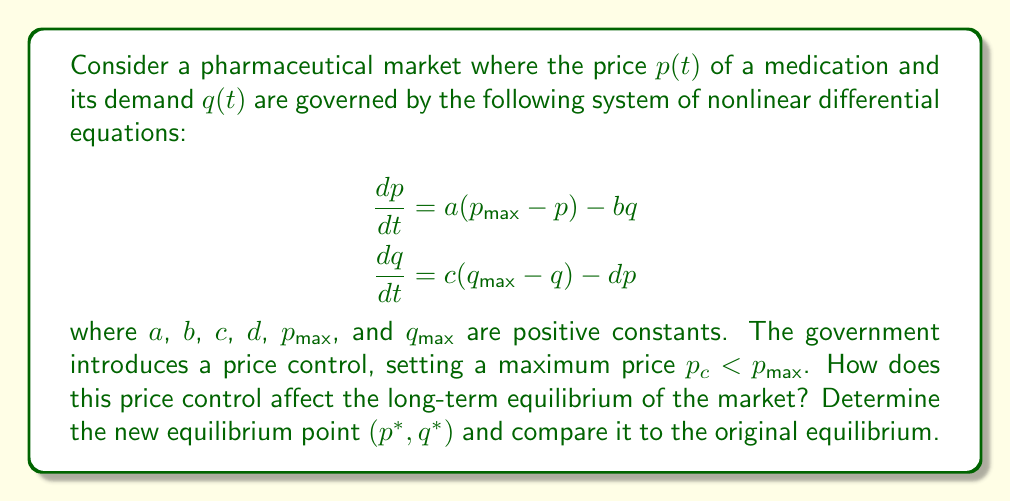Could you help me with this problem? To solve this problem, we'll follow these steps:

1) First, let's find the original equilibrium point without price controls. At equilibrium, both derivatives are zero:

   $$\begin{aligned}
   0 &= a(p_{max} - p) - bq \\
   0 &= c(q_{max} - q) - dp
   \end{aligned}$$

2) Solving these equations simultaneously:

   $$\begin{aligned}
   p^* &= \frac{acp_{max} + bcq_{max}}{ac + bd} \\
   q^* &= \frac{adq_{max} + cdp_{max}}{ac + bd}
   \end{aligned}$$

3) Now, with the price control $p_c$, the equilibrium price cannot exceed $p_c$. If $p^* < p_c$, the equilibrium remains unchanged. If $p^* > p_c$, the new equilibrium price will be $p_c$.

4) Assuming $p^* > p_c$, we need to find the new equilibrium quantity. We substitute $p = p_c$ into the second equation:

   $$0 = c(q_{max} - q) - dp_c$$

5) Solving for $q$:

   $$q_{new}^* = q_{max} - \frac{dp_c}{c}$$

6) The new equilibrium point is $(p_c, q_{max} - \frac{dp_c}{c})$.

7) Comparing to the original equilibrium:
   - The price is lower: $p_c < p^*$
   - The quantity may be higher or lower, depending on the values of the parameters. If $q_{max} - \frac{dp_c}{c} > q^*$, quantity increases; otherwise, it decreases.

8) The long-term effects of the price control include:
   - Guaranteed lower prices for consumers
   - Possible shortage if the equilibrium quantity decreases
   - Reduced incentives for pharmaceutical companies if profits decrease
   - Potential impact on research and development of new medications
Answer: New equilibrium: $(p_c, q_{max} - \frac{dp_c}{c})$. Price decreases; quantity may increase or decrease. 